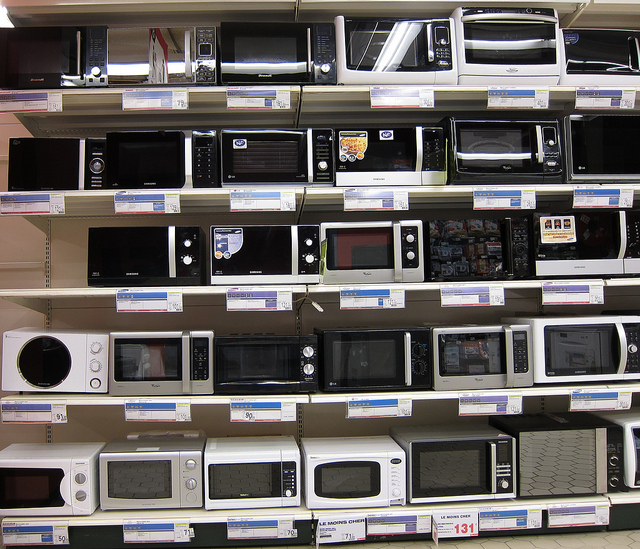Please transcribe the text information in this image. 131 